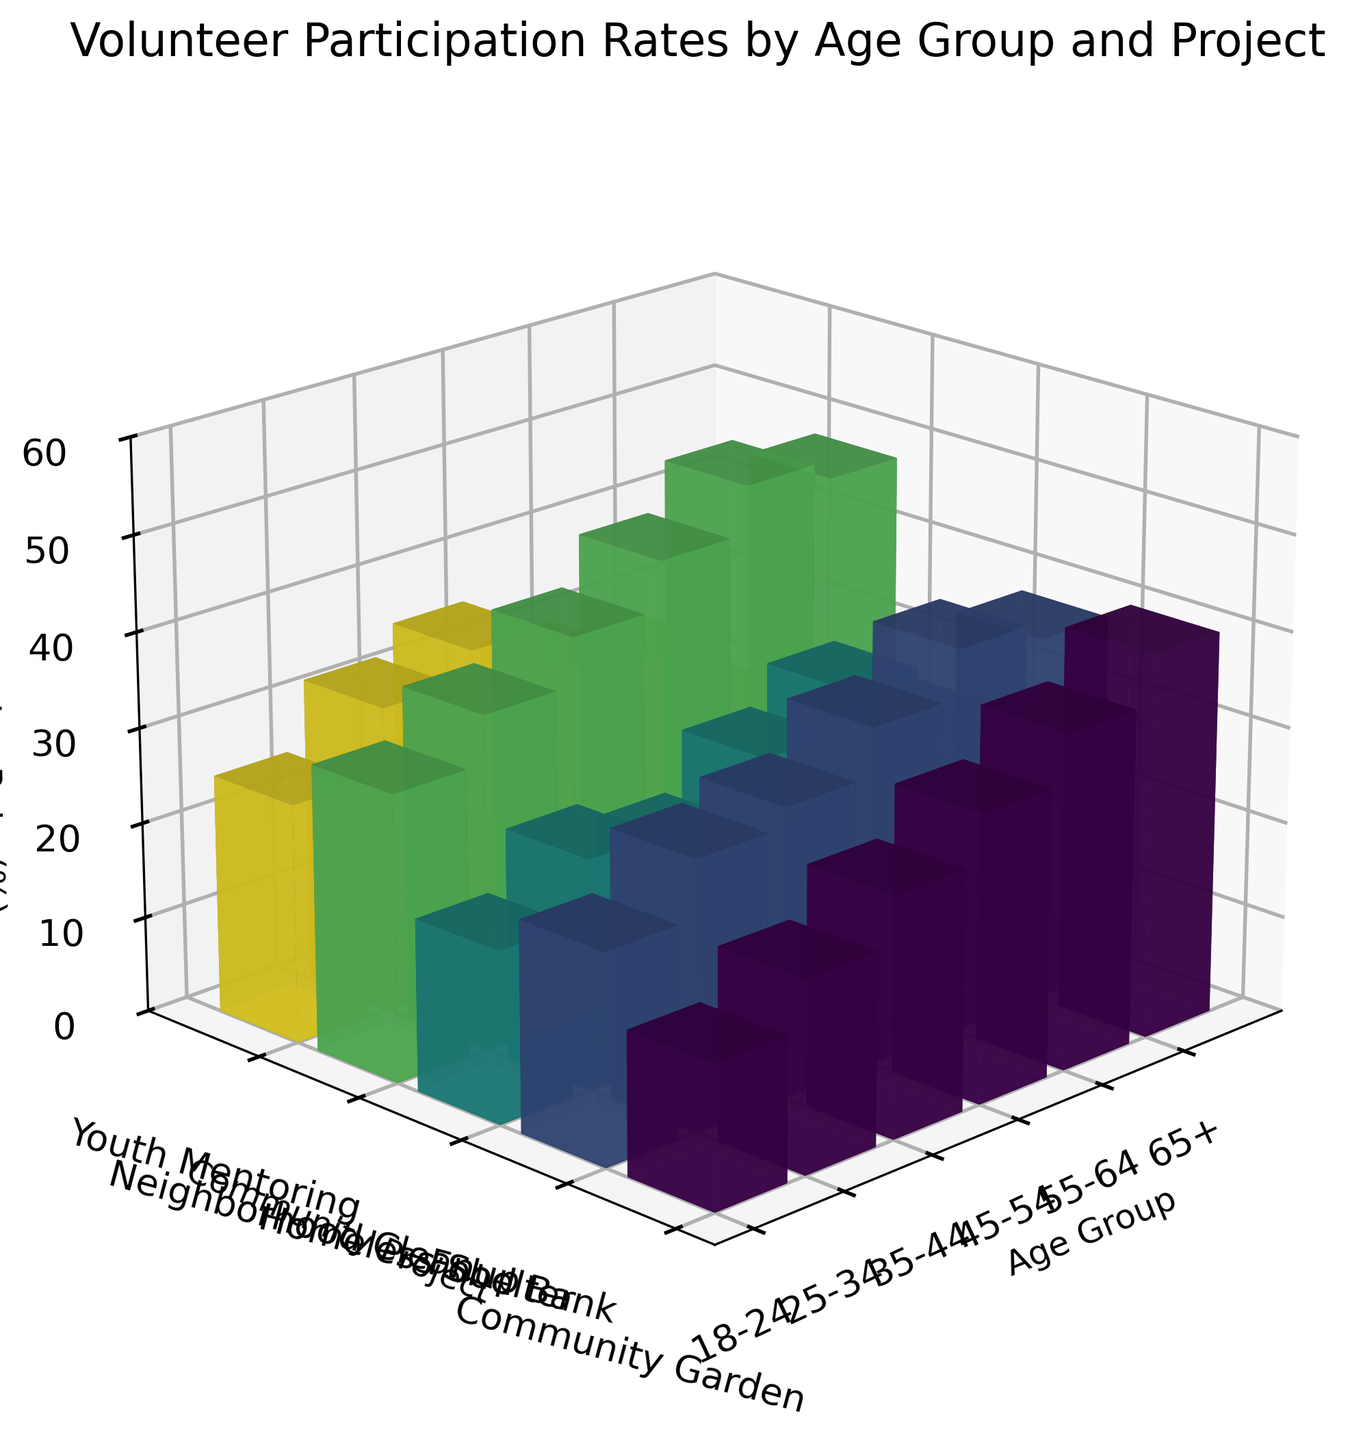What is the title of the 3D bar plot? The title is located at the top of the plot, indicating what the figure represents.
Answer: Volunteer Participation Rates by Age Group and Project Which axis represents the age groups in the plot? The labels on one of the axes will show the age groups such as 18-24, 25-34, etc.
Answer: The x-axis How many different community projects are displayed in the figure? Each community project is represented as a separate category on the y-axis. Count these categories to find the number.
Answer: 5 Which age group has the highest participation rate in the Community Garden project? Find the tallest bar in the Community Garden category and identify the corresponding age group on the x-axis.
Answer: 65+ What is the participation rate for the 45-54 age group in the Youth Mentoring project? Locate the 45-54 age group on the x-axis and find the corresponding bar under the Youth Mentoring category. The height of the bar gives the participation rate.
Answer: 30 Which community project shows the most participation from the 25-34 age group? Look at the bars associated with the 25-34 age group across all community projects and identify the tallest one.
Answer: Neighborhood Cleanup What is the average participation rate in the Food Bank project across all age groups? Sum up the participation rates for the Food Bank project across all age groups and divide by the number of age groups.
Answer: 32.2 In which project do older age groups (55-64 and 65+) collectively participate more than younger age groups (18-24 and 25-34)? Compare the summed values of participation rates for older age groups vs. younger age groups across each project.
Answer: Community Garden Which project shows the least variation in participation rates across different age groups? Look across all projects and compare the differences in bar heights for each age group, identifying the project with the smallest differences.
Answer: Youth Mentoring If participation in the Food Bank and Homeless Shelter projects were combined, what would be the total participation rate for the 35-44 age group? Add the participation rates for the 35-44 age group in the Food Bank and Homeless Shelter projects.
Answer: 52 